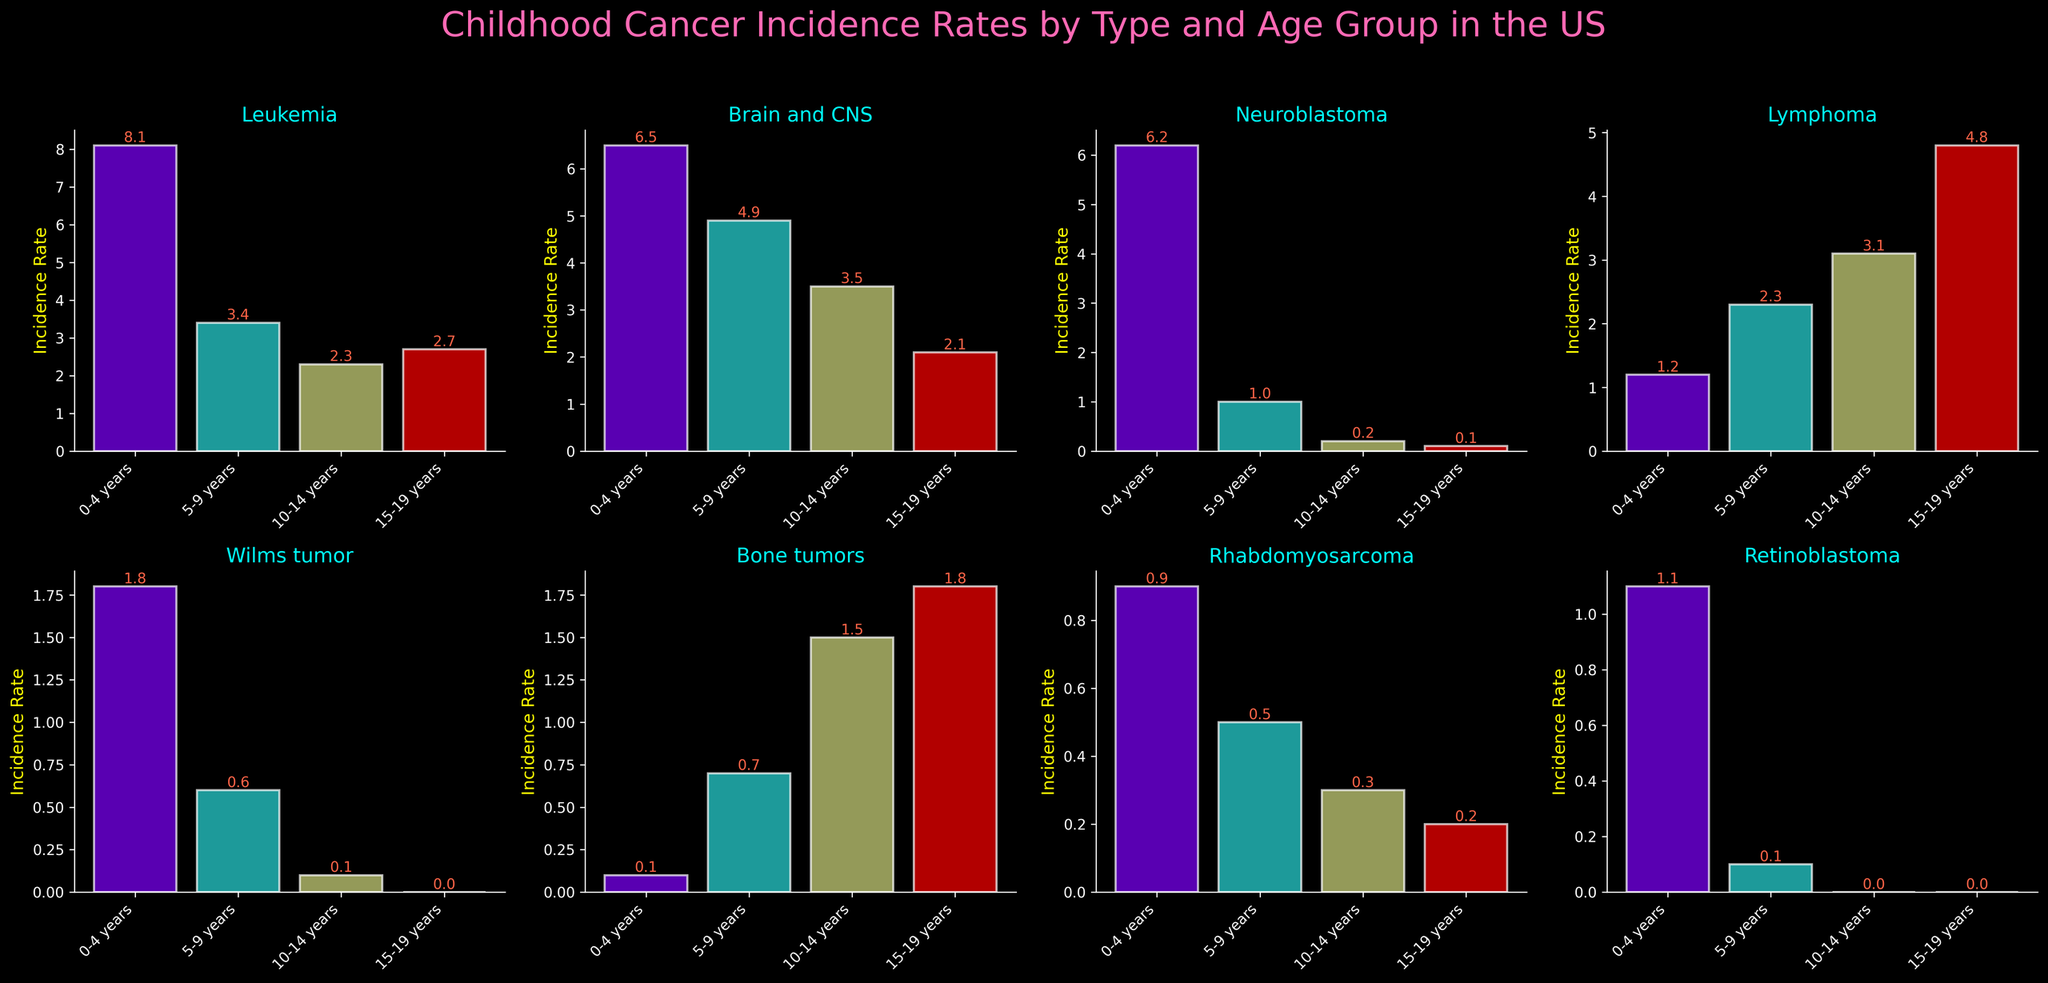Which cancer type has the highest incidence rate for the age group 0-4 years? Look at the subplot for each cancer type and compare the height of the bars for the age group 0-4 years. The highest bar in the 0-4 years age group belongs to Leukemia.
Answer: Leukemia Which age group has the highest incidence rate for Bone tumors? Find the subplot for Bone tumors and compare the height of the bars for each age group. The highest bar is for the age group 15-19 years.
Answer: 15-19 years What is the total incidence rate for Rhabdomyosarcoma across all age groups? Locate the subplot for Rhabdomyosarcoma and add the values of the bars for all age groups: 0.9 + 0.5 + 0.3 + 0.2.
Answer: 1.9 Compare the highest incidence rates of Leukemia and Brain and CNS cancers. Which one is higher and by how much? Look at the highest bars in the subplots for Leukemia (8.1 for 0-4 years) and Brain and CNS (6.5 for 0-4 years). Subtract the Brain and CNS rate from the Leukemia rate: 8.1 - 6.5.
Answer: Leukemia, 1.6 Which cancer type shows a pattern of decreasing incidence rates with increasing age groups? Examine the subplots and look for a pattern where the bars decrease in height consistently from left to right. Neuroblastoma shows this pattern with bars decreasing from 6.2 to 1.0 to 0.2 to 0.1.
Answer: Neuroblastoma What is the incidence rate difference between the highest and lowest age groups for Wilms tumor? Find the values in the subplot for Wilms tumor: 1.8 (0-4 years) and 0.0 (15-19 years). Subtract the lowest value from the highest: 1.8 - 0.0.
Answer: 1.8 What is the average incidence rate for Retinoblastoma across the age groups? Locate the subplot for Retinoblastoma. Add the incidence rates and divide by the number of age groups: (1.1 + 0.1 + 0.0 + 0.0) / 4.
Answer: 0.3 For which age group does Lymphoma have the highest incidence rate? Examine the subplot for Lymphoma and determine which bar is the tallest. The highest incidence rate is for the age group 15-19 years.
Answer: 15-19 years Is the incidence rate of Neuroblastoma in the age group 5-9 years higher or lower than that of Rhabdomyosarcoma in the same age group? Compare the values in the subplots for Neuroblastoma (1.0) and Rhabdomyosarcoma (0.5) for the age group 5-9 years. Neuroblastoma has a higher incidence rate.
Answer: Higher How does the incidence rate of Wilms tumor in the 0-4 years age group compare to the incidence rate of Bone tumors in the same age group? Compare the bars in the subplots for Wilms tumor (1.8) and Bone tumors (0.1) in the 0-4 years age group. Wilms tumor has a higher incidence rate.
Answer: Wilms tumor, 1.7 